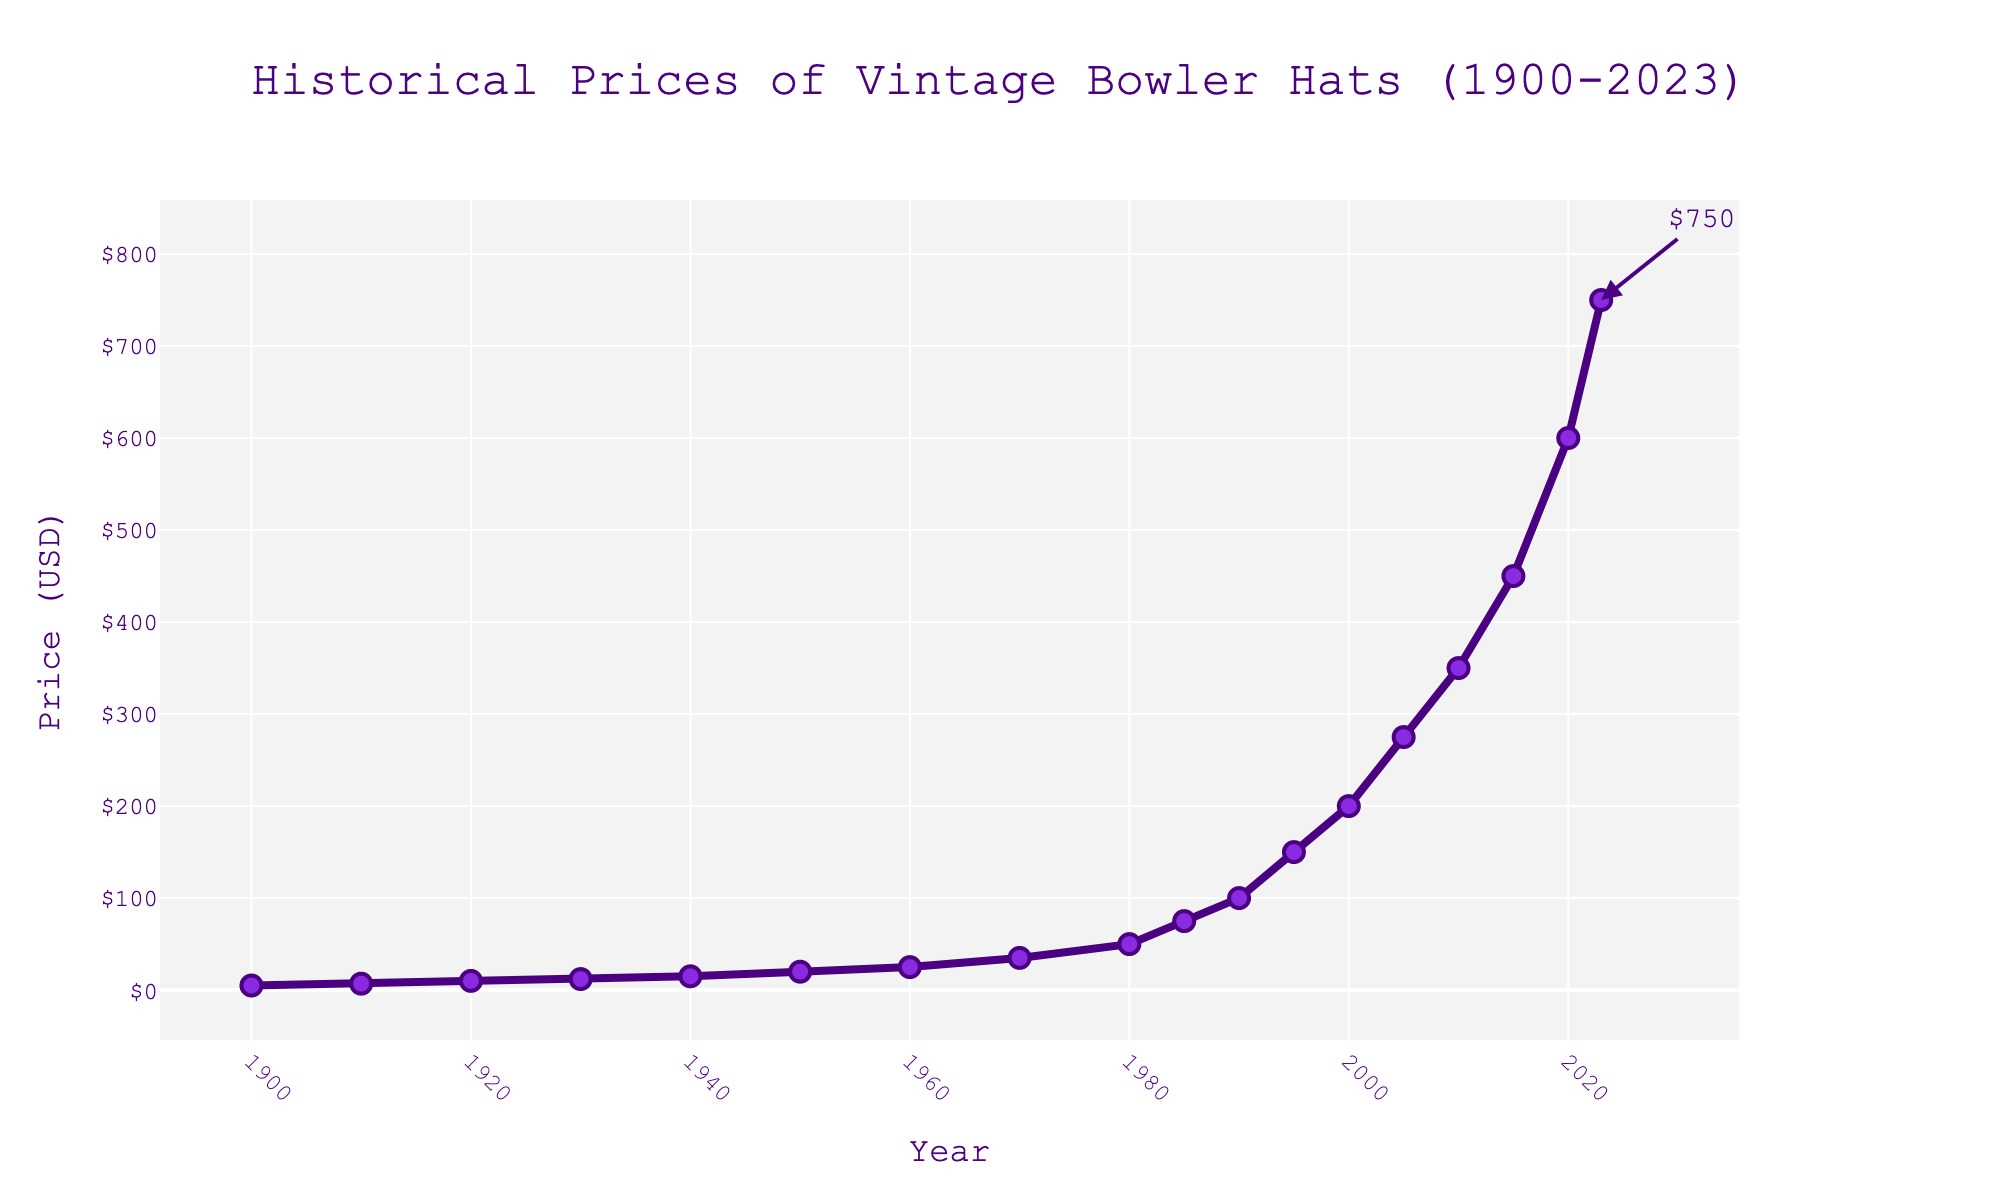What year did the average price of vintage bowler hats first exceed $50? To find the year when the average price first surpassed $50, we look at the data points. In the year 1980, the price was $50, and by 1985 it had reached $75. Thus, 1985 is the first year the price exceeded $50.
Answer: 1985 In which decade did the average price of vintage bowler hats increase by the highest amount? To determine the decade with the highest price increase, we calculate the price increases for each decade: 1900-1910 ($2), 1910-1920 ($3), ..., 2010-2020 ($150). The decade with the greatest increase is 2010-2020, where the price jumped by $150.
Answer: 2010-2020 What is the ratio of the average price in 2023 to the average price in 2000? To find this ratio, divide the average price in 2023 ($750) by the average price in 2000 ($200). The calculation is $750 / $200 = 3.75.
Answer: 3.75 What is the difference between the average prices in 1990 and 1985? To find the difference, subtract the average price in 1985 ($75) from the average price in 1990 ($100). The calculation is $100 - $75 = $25.
Answer: $25 How many years did it take for the average price to rise from $10 to $100? Identify the years where the average prices were $10 (1920) and $100 (1990). Subtract 1920 from 1990 to find the number of years, which gives 1990 - 1920 = 70 years.
Answer: 70 During which period did the average price remain static or nearly static? We look for periods where the price change is minimal. From the data, between 1980 ($50) and 1985 ($75), and also in the early 20th century between 1900 ($5) and 1910 ($7), the increases are relatively small ($25 and $2 respectively).
Answer: 1900-1910 and 1980-1985 What was the average price increase per decade from 2000 to 2020? Calculate the average price increase over 20 years. The price increased from $200 in 2000 to $600 in 2020, a total increase of $400. Divide by 2 to find the average per decade, $400 / 2 = $200.
Answer: $200 Compare the price jump between 1970 to 1980 and 2020 to 2023. Which period had a greater increase? From 1970 ($35) to 1980 ($50), the increase was $15. From 2020 ($600) to 2023 ($750), the increase was $150. The period of 2020 to 2023 had a much greater increase.
Answer: 2020 to 2023 